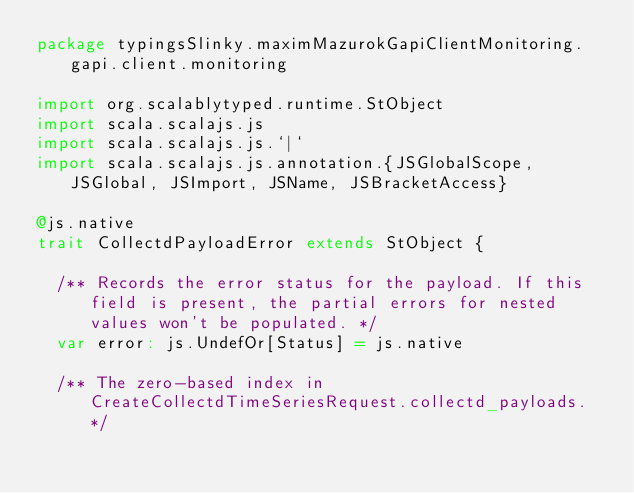Convert code to text. <code><loc_0><loc_0><loc_500><loc_500><_Scala_>package typingsSlinky.maximMazurokGapiClientMonitoring.gapi.client.monitoring

import org.scalablytyped.runtime.StObject
import scala.scalajs.js
import scala.scalajs.js.`|`
import scala.scalajs.js.annotation.{JSGlobalScope, JSGlobal, JSImport, JSName, JSBracketAccess}

@js.native
trait CollectdPayloadError extends StObject {
  
  /** Records the error status for the payload. If this field is present, the partial errors for nested values won't be populated. */
  var error: js.UndefOr[Status] = js.native
  
  /** The zero-based index in CreateCollectdTimeSeriesRequest.collectd_payloads. */</code> 